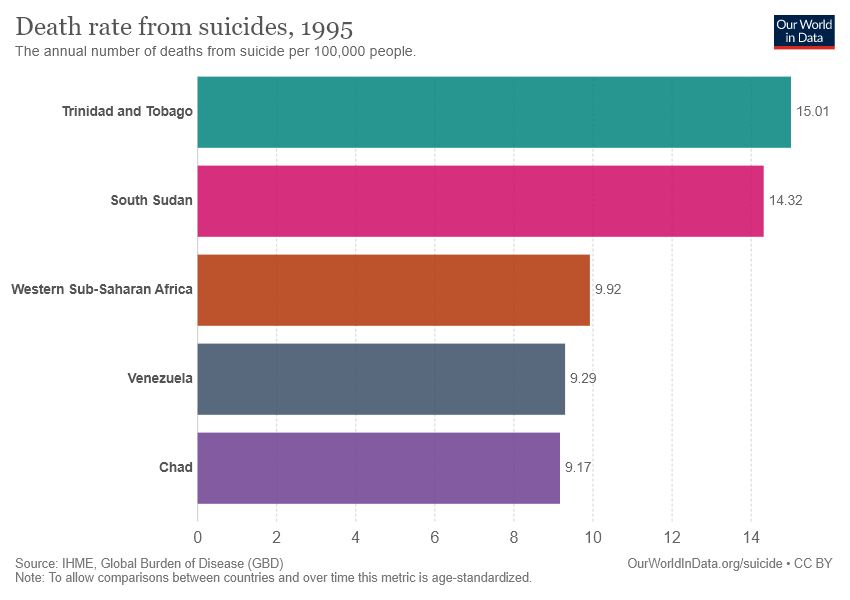Identify some key points in this picture. The sum of the smallest two bars is greater than the value of the largest bar. The country represented by the pink bar is South Sudan. 